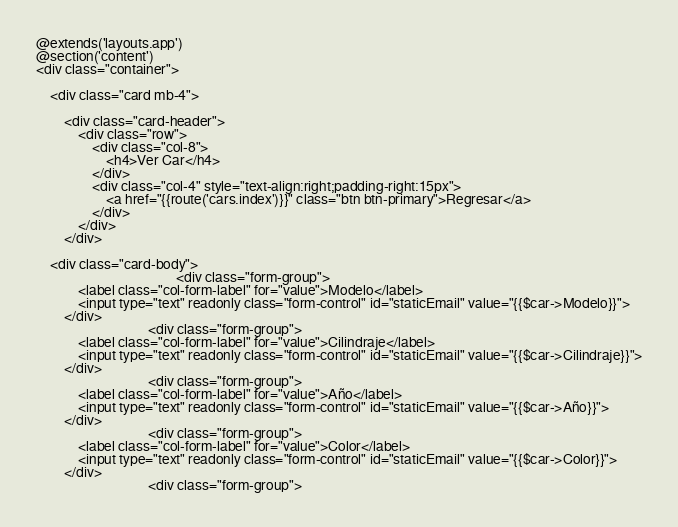Convert code to text. <code><loc_0><loc_0><loc_500><loc_500><_PHP_>@extends('layouts.app')
@section('content')
<div class="container">

    <div class="card mb-4">

        <div class="card-header">
            <div class="row">
                <div class="col-8">
                    <h4>Ver Car</h4>
                </div>
                <div class="col-4" style="text-align:right;padding-right:15px"> 
                    <a href="{{route('cars.index')}}" class="btn btn-primary">Regresar</a>
                </div>
            </div>
        </div>

    <div class="card-body">
                                        <div class="form-group">
            <label class="col-form-label" for="value">Modelo</label>
            <input type="text" readonly class="form-control" id="staticEmail" value="{{$car->Modelo}}">
        </div>
                                <div class="form-group">
            <label class="col-form-label" for="value">Cilindraje</label>
            <input type="text" readonly class="form-control" id="staticEmail" value="{{$car->Cilindraje}}">
        </div>
                                <div class="form-group">
            <label class="col-form-label" for="value">Año</label>
            <input type="text" readonly class="form-control" id="staticEmail" value="{{$car->Año}}">
        </div>
                                <div class="form-group">
            <label class="col-form-label" for="value">Color</label>
            <input type="text" readonly class="form-control" id="staticEmail" value="{{$car->Color}}">
        </div>
                                <div class="form-group"></code> 